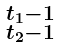<formula> <loc_0><loc_0><loc_500><loc_500>\begin{smallmatrix} t _ { 1 } - 1 \\ t _ { 2 } - 1 \end{smallmatrix}</formula> 